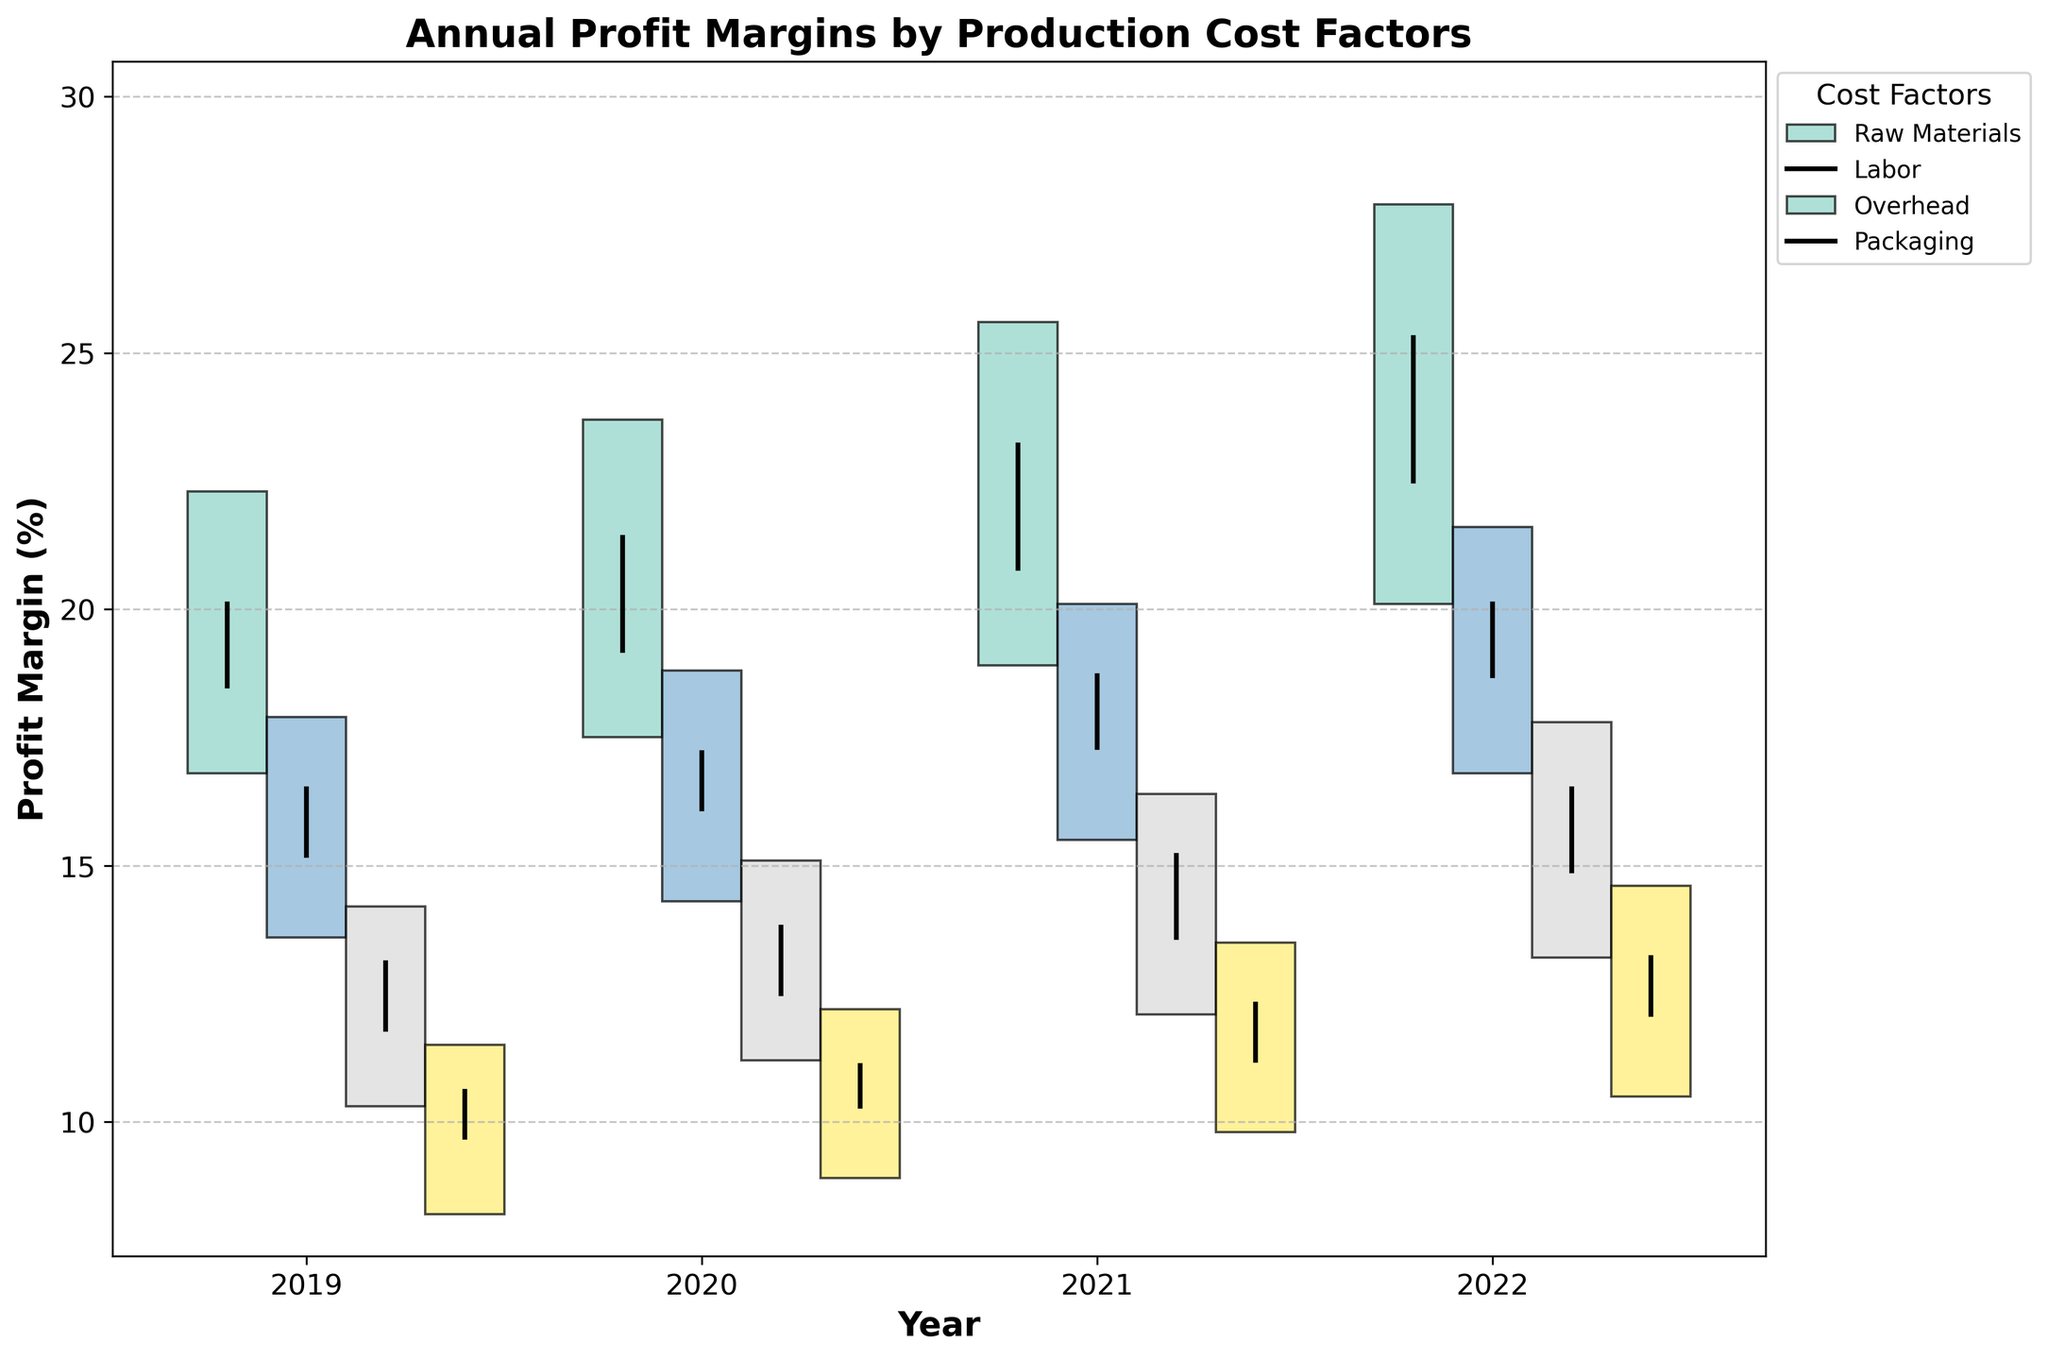How many cost factors are represented in the chart? By observing the legend on the right side of the chart, we can see the different cost factors listed. Count the distinct cost factors mentioned.
Answer: 4 What is the title of the chart? The title is located at the top center of the chart, above the plot area.
Answer: Annual Profit Margins by Production Cost Factors Which year recorded the highest close value for raw materials? Look for the bar labeled 'Raw Materials' and observe the 'Close' values for each year. Find the highest 'Close' value among those years.
Answer: 2022 What is the difference in the 'Close' value between 2021 and 2022 for the labor cost factor? Identify the 'Close' values for labor in both years from the chart. Subtract the 'Close' value of 2021 from that of 2022.
Answer: 20.1 - 18.7 = 1.4 Which cost factor had the lowest 'Low' value in 2019? Locate the year 2019 and compare the 'Low' values of all cost factors for this year. Identify the cost factor with the lowest 'Low' value.
Answer: Packaging Which year shows the greatest range between 'High' and 'Low' for overhead costs? For each year, calculate the range by subtracting the 'Low' value from the 'High' value for overhead costs. Determine the year with the largest range.
Answer: 2022 (range: 17.8 - 13.2 = 4.6) What is the average 'Open' value of packaging from 2019 to 2022? Sum the 'Open' values for packaging across the years 2019 to 2022, then divide by the number of years.
Answer: (9.7 + 10.3 + 11.2 + 12.1) / 4 = 10.825 Which cost factor had a positive change in the 'Close' value every year from 2019 to 2022? Compare the 'Close' values year-over-year for each cost factor. Identify the cost factor with consistently increasing 'Close' values.
Answer: Raw Materials How does the 'High' value for 2022 raw materials compare to that in 2019? Look at the 'High' values for raw materials in both years and perform a direct comparison.
Answer: 27.9 (2022) is greater than 22.3 (2019) What is the total 'High' value for labor across all years? Sum the 'High' values of labor from each year from 2019 to 2022.
Answer: 17.9 + 18.8 + 20.1 + 21.6 = 78.4 